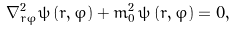Convert formula to latex. <formula><loc_0><loc_0><loc_500><loc_500>\nabla _ { r \varphi } ^ { 2 } \psi \left ( r , \varphi \right ) + m _ { 0 } ^ { 2 } \, \psi \left ( r , \varphi \right ) = 0 ,</formula> 